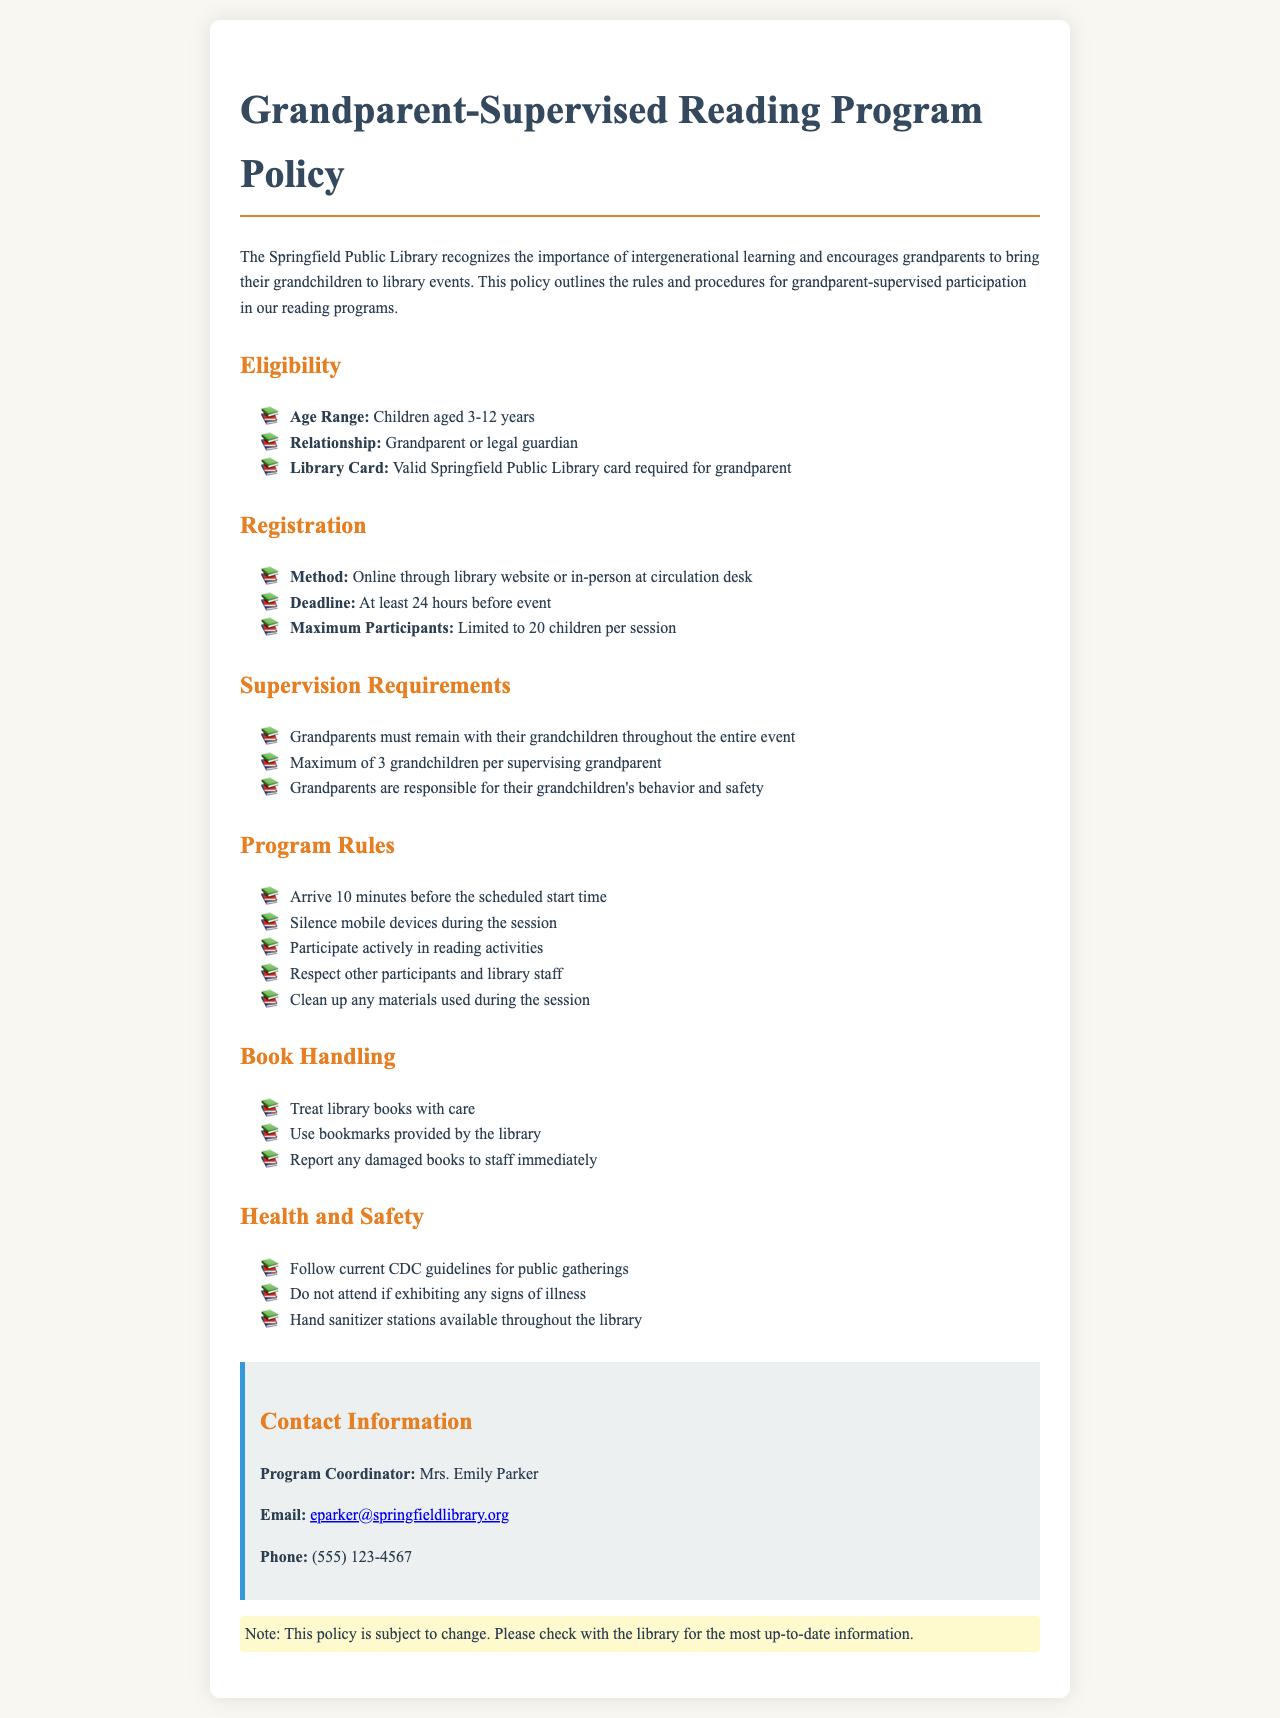What is the age range for children? The policy specifies that children who participate must be aged between 3 and 12 years.
Answer: 3-12 years Who must supervise the children? The document states that a grandparent or legal guardian is required to supervise the children during the event.
Answer: Grandparent or legal guardian What is the maximum number of children a grandparent can supervise? According to the policy, a grandparent can supervise a maximum of three grandchildren.
Answer: 3 grandchildren What is the registration deadline? The policy indicates that registration must be completed at least 24 hours before the event.
Answer: 24 hours What is the maximum number of children allowed per session? The document states that the maximum number of participants per session is limited to 20 children.
Answer: 20 children What type of library card is required for grandparents? The policy specifies that a valid Springfield Public Library card is required for grandparents.
Answer: Valid Springfield Public Library card What must participants do with library books? The document mentions that participants should treat library books with care and use bookmarks provided by the library.
Answer: Treat library books with care Who is the program coordinator? The contact information section of the document identifies Mrs. Emily Parker as the program coordinator.
Answer: Mrs. Emily Parker 